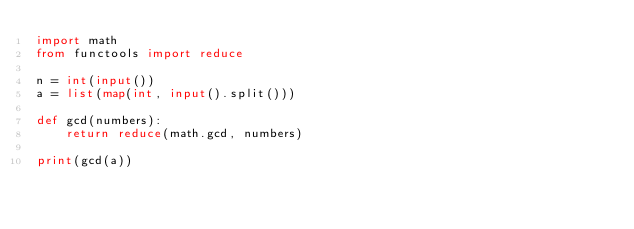<code> <loc_0><loc_0><loc_500><loc_500><_Python_>import math
from functools import reduce

n = int(input())
a = list(map(int, input().split()))

def gcd(numbers):
    return reduce(math.gcd, numbers)
  
print(gcd(a))</code> 